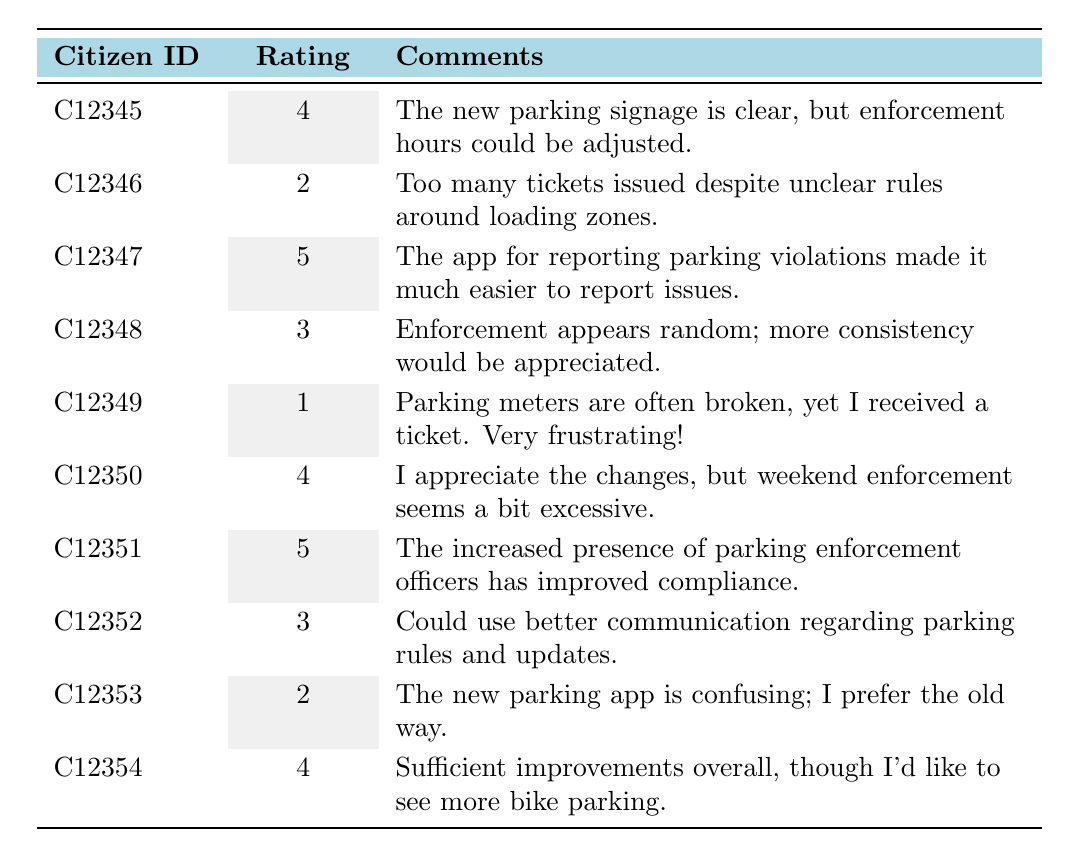What is the highest rating given by a citizen? The highest rating in the table is 5, which is given by Citizen IDs C12347 and C12351.
Answer: 5 What comments did Citizen C12349 provide? Citizen C12349 stated that parking meters are often broken and expressed frustration at receiving a ticket despite this issue.
Answer: Parking meters are often broken; received a ticket How many citizens rated the parking enforcement system positively (ratings of 4 or 5)? The positive ratings of 4 or 5 were given by Citizens C12345, C12347, C12350, and C12351. There are a total of 4 positive ratings.
Answer: 4 What is the average rating from all citizens? To find the average, sum all the ratings: (4 + 2 + 5 + 3 + 1 + 4 + 5 + 3 + 2 + 4) = 33. Then divide by the number of ratings (10): 33 / 10 = 3.3.
Answer: 3.3 Is there a citizen who expressed concerns about the clarity of parking rules? Yes, Citizen C12346 mentioned that there are too many tickets issued despite unclear rules around loading zones.
Answer: Yes Which citizen mentioned the requirement for better communication regarding parking rules? Citizen C12352 commented on the need for better communication regarding parking rules and updates.
Answer: Citizen C12352 Count the amount of citizens who rated the enforcement system below average (ratings of 3 or less). Citizens C12346, C12349, C12353 rated the system below average, making a total of 3 citizens.
Answer: 3 What feedback did C12350 provide regarding weekend enforcement? C12350 appreciates the changes but thinks that weekend enforcement seems excessive.
Answer: Excessive weekend enforcement Which citizen rated the new parking app negatively? Citizen C12353 found the new parking app confusing and preferred the old method.
Answer: Citizen C12353 Among the citizens who liked the new enforcement changes, who suggested more bike parking? Citizen C12354 appreciated the improvements overall but suggested adding more bike parking.
Answer: Citizen C12354 